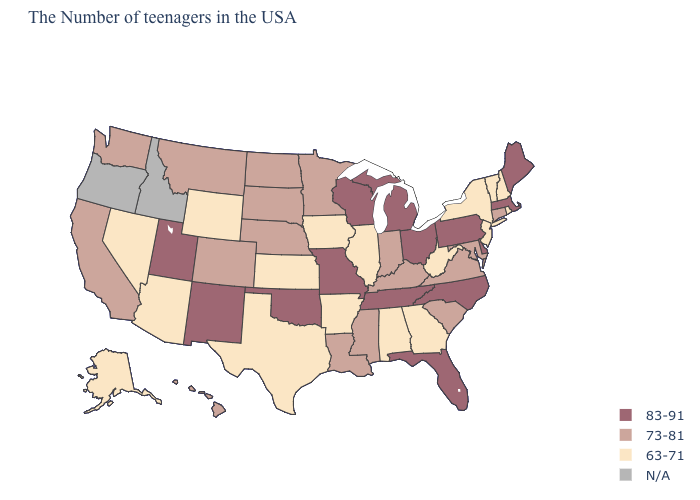Which states have the highest value in the USA?
Answer briefly. Maine, Massachusetts, Delaware, Pennsylvania, North Carolina, Ohio, Florida, Michigan, Tennessee, Wisconsin, Missouri, Oklahoma, New Mexico, Utah. What is the lowest value in the West?
Quick response, please. 63-71. What is the value of North Carolina?
Answer briefly. 83-91. Name the states that have a value in the range 83-91?
Be succinct. Maine, Massachusetts, Delaware, Pennsylvania, North Carolina, Ohio, Florida, Michigan, Tennessee, Wisconsin, Missouri, Oklahoma, New Mexico, Utah. Which states have the lowest value in the USA?
Keep it brief. Rhode Island, New Hampshire, Vermont, New York, New Jersey, West Virginia, Georgia, Alabama, Illinois, Arkansas, Iowa, Kansas, Texas, Wyoming, Arizona, Nevada, Alaska. Name the states that have a value in the range 73-81?
Quick response, please. Connecticut, Maryland, Virginia, South Carolina, Kentucky, Indiana, Mississippi, Louisiana, Minnesota, Nebraska, South Dakota, North Dakota, Colorado, Montana, California, Washington, Hawaii. What is the value of New Hampshire?
Give a very brief answer. 63-71. What is the value of Delaware?
Quick response, please. 83-91. What is the lowest value in the MidWest?
Give a very brief answer. 63-71. What is the value of Missouri?
Concise answer only. 83-91. Name the states that have a value in the range N/A?
Answer briefly. Idaho, Oregon. What is the value of Pennsylvania?
Quick response, please. 83-91. What is the value of Rhode Island?
Write a very short answer. 63-71. What is the value of North Dakota?
Quick response, please. 73-81. 